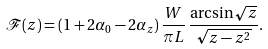Convert formula to latex. <formula><loc_0><loc_0><loc_500><loc_500>\mathcal { F } ( z ) = ( 1 + 2 \alpha _ { 0 } - 2 \alpha _ { z } ) \, \frac { W } { \pi L } \, \frac { \arcsin \sqrt { z } } { \sqrt { z - z ^ { 2 } } } .</formula> 